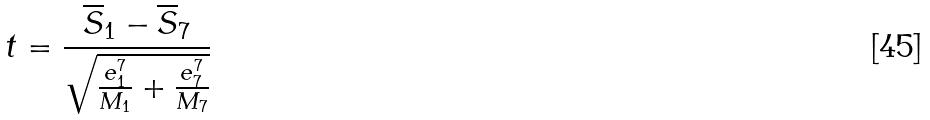Convert formula to latex. <formula><loc_0><loc_0><loc_500><loc_500>t = \frac { \overline { S } _ { 1 } - \overline { S } _ { 7 } } { \sqrt { \frac { e _ { 1 } ^ { 7 } } { M _ { 1 } } + \frac { e _ { 7 } ^ { 7 } } { M _ { 7 } } } }</formula> 